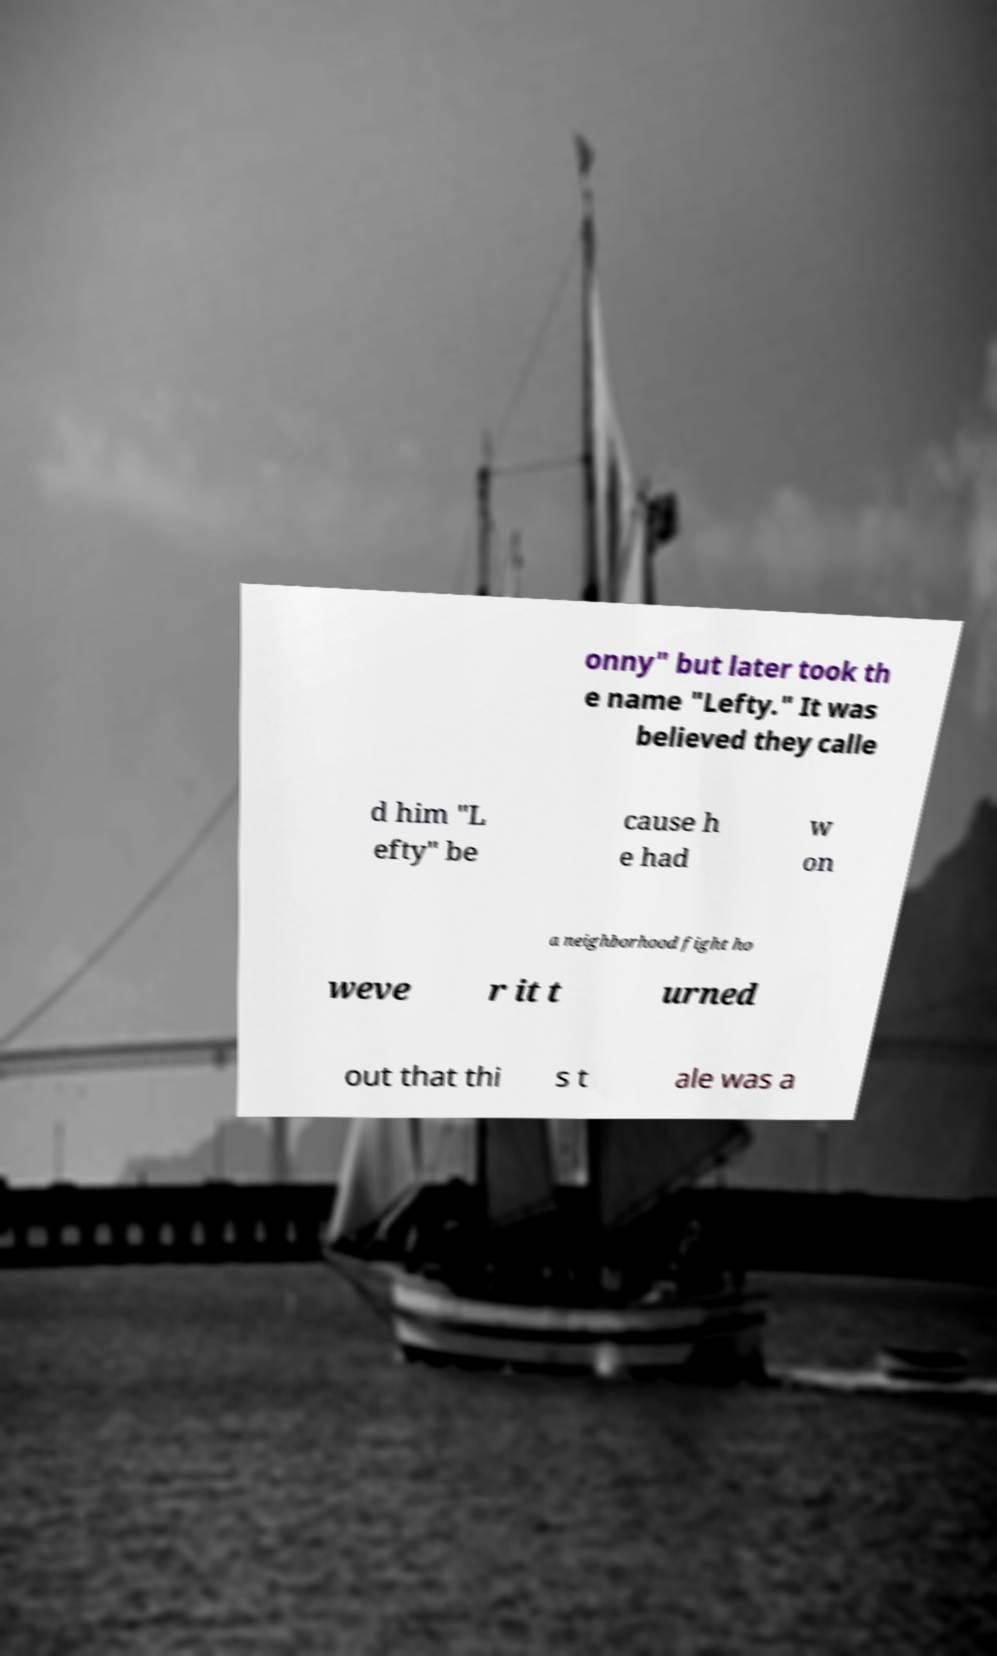Could you extract and type out the text from this image? onny" but later took th e name "Lefty." It was believed they calle d him "L efty" be cause h e had w on a neighborhood fight ho weve r it t urned out that thi s t ale was a 